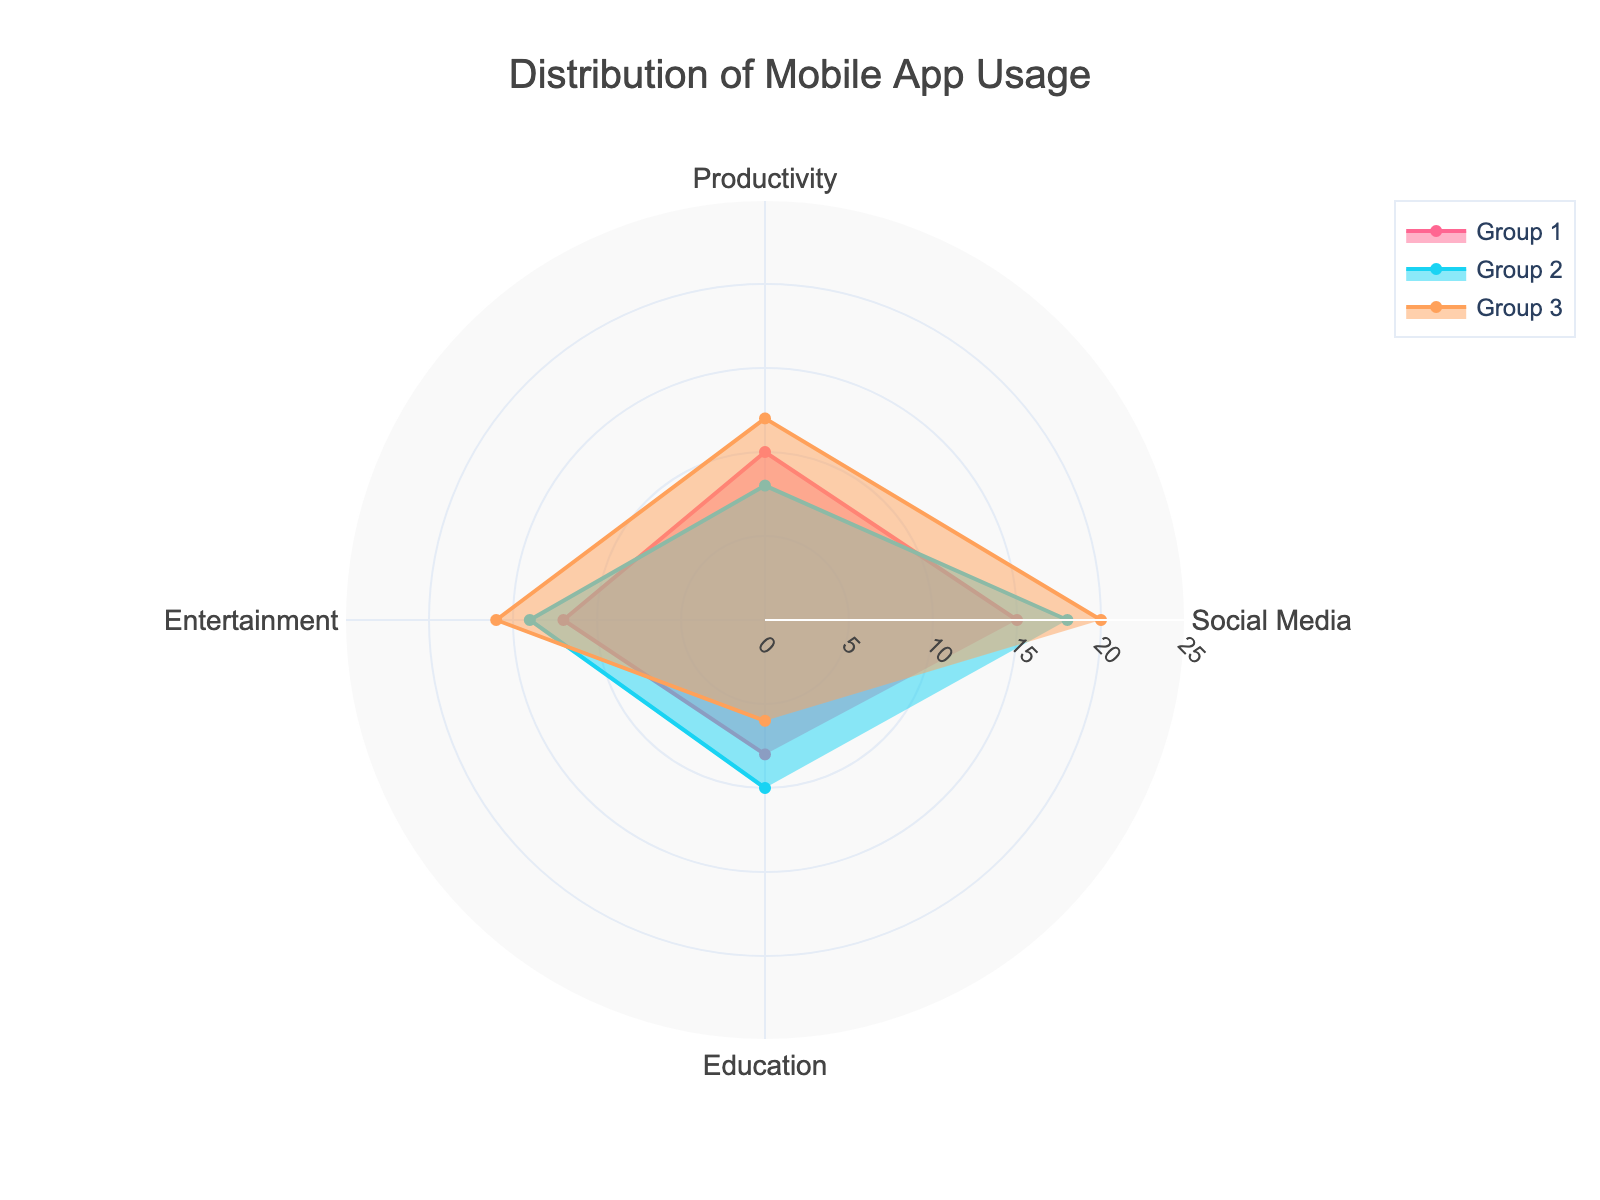What is the title of the figure? The title is usually placed at the top center of the figure. It provides an overview of what the chart is about. In this case, the title is "Distribution of Mobile App Usage".
Answer: Distribution of Mobile App Usage Which group has the highest average usage hours in the Social Media category? In the Social Media category, we can compare the specific points where each group's line intersects this category on the radar chart. The intersection point that is farthest from the center represents the highest value.
Answer: Group 3 What is the average usage hours for Productivity in Group 2? Locate the point where Group 2's line intersects with the Productivity category. This point represents the value for average usage hours. From the chart, it is easy to identify this value.
Answer: 8 How does the average usage in Education compare between Group 1 and Group 3? Check the intersection points for Group 1 and Group 3 within the Education category on the radar chart. Group 1 and Group 3 intersect at 8 hours and 6 hours respectively. Group 1 has a higher usage than Group 3 in this category.
Answer: Group 1 has higher usage What’s the combined average usage for Entertainment and Education in Group 1? Group 1's average usage for Entertainment is 12 hours and for Education is 8 hours. Add these two values: 12 + 8 = 20 hours.
Answer: 20 hours Which app category is the most used by Group 2 and what is the usage? Look at where Group 2 reaches its farthest point from the center across all categories. The farthest point corresponds to the highest average usage hours. For Group 2, the highest value is in the Social Media category at 18 hours.
Answer: Social Media, 18 hours In which category do Group 1 and Group 2 have equal usage? Compare the intersection points of Group 1 and Group 2 within each category on the radar chart. These points align only if the values are equal. In this case, none of the categories have equal usage between Group 1 and Group 2.
Answer: None What is the difference in average usage for Social Media between Group 1 and Group 3? Evaluate the intersection points in the Social Media category for Group 1 and Group 3. Group 1 has 15 hours and Group 3 has 20 hours. Subtract the smaller value from the larger one: 20 - 15 = 5 hours.
Answer: 5 hours 